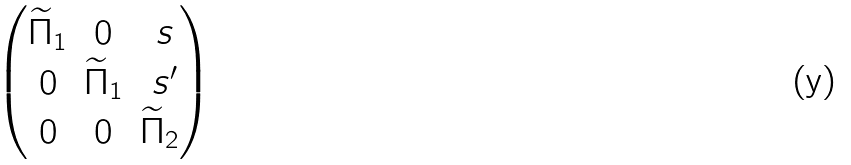<formula> <loc_0><loc_0><loc_500><loc_500>\begin{pmatrix} { \widetilde { \Pi } } _ { 1 } & 0 & \ s \\ 0 & { \widetilde { \Pi } } _ { 1 } & \ s ^ { \prime } \\ 0 & 0 & { \widetilde { \Pi } } _ { 2 } \end{pmatrix}</formula> 